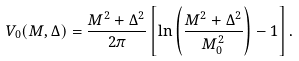Convert formula to latex. <formula><loc_0><loc_0><loc_500><loc_500>V _ { 0 } ( M , \Delta ) = \frac { M ^ { 2 } + \Delta ^ { 2 } } { 2 \pi } \left [ \ln \left ( \frac { M ^ { 2 } + \Delta ^ { 2 } } { M ^ { 2 } _ { 0 } } \right ) - 1 \right ] .</formula> 